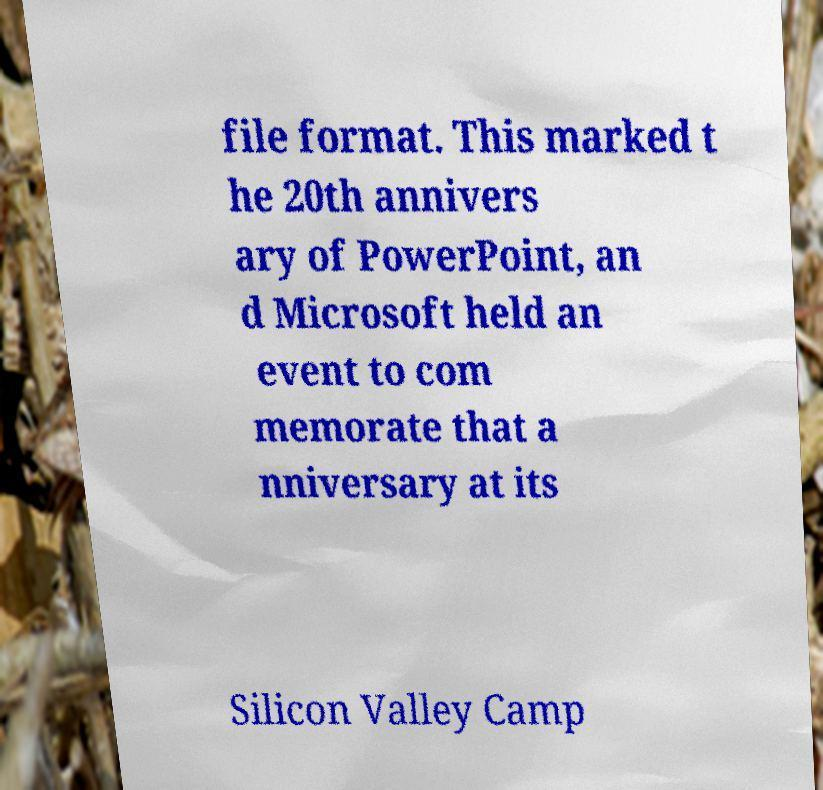Can you read and provide the text displayed in the image?This photo seems to have some interesting text. Can you extract and type it out for me? file format. This marked t he 20th annivers ary of PowerPoint, an d Microsoft held an event to com memorate that a nniversary at its Silicon Valley Camp 